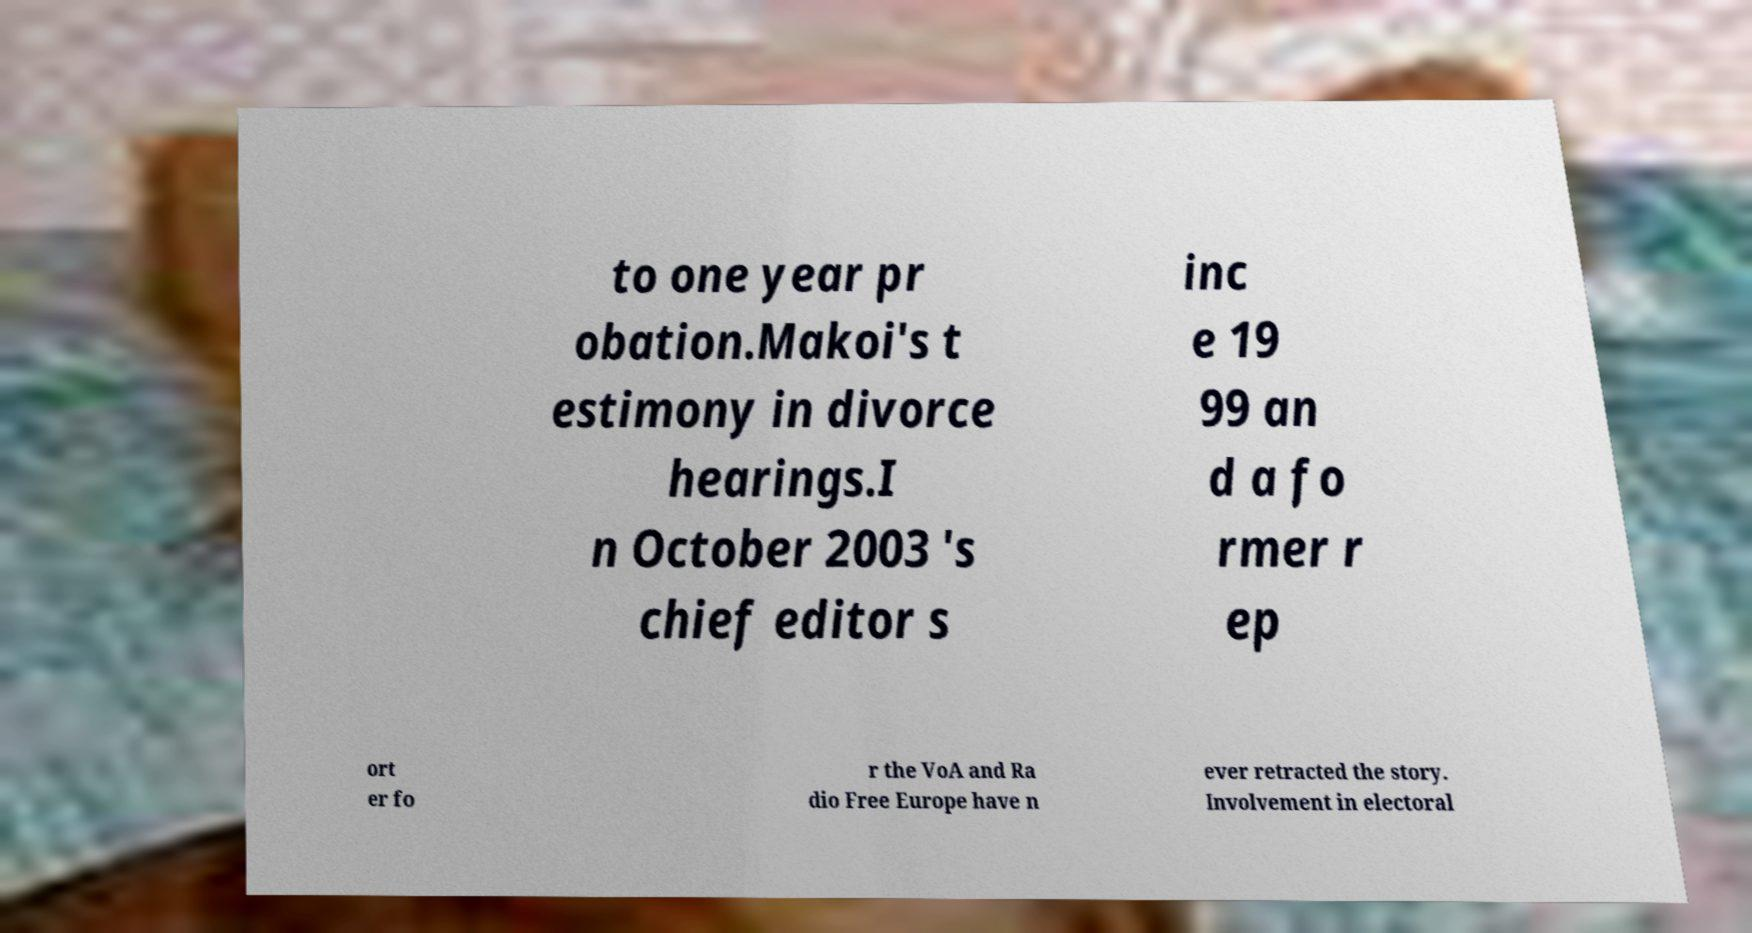Can you read and provide the text displayed in the image?This photo seems to have some interesting text. Can you extract and type it out for me? to one year pr obation.Makoi's t estimony in divorce hearings.I n October 2003 's chief editor s inc e 19 99 an d a fo rmer r ep ort er fo r the VoA and Ra dio Free Europe have n ever retracted the story. Involvement in electoral 